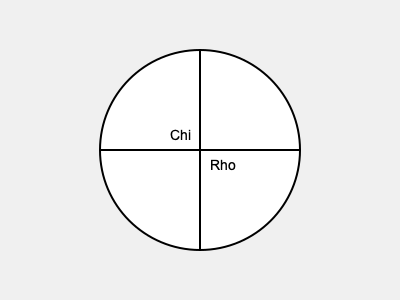What is the name of this important symbol in Episcopal worship, and what does it represent? 1. The symbol shown in the image is known as the Chi-Rho symbol.

2. It is composed of two Greek letters superimposed on each other:
   - The letter Chi (X), which looks like an X in the English alphabet
   - The letter Rho (P), which looks like a P in the English alphabet

3. These letters are the first two letters of the Greek word "Christos," meaning "Christ."

4. The Chi-Rho is one of the earliest Christian symbols, dating back to the 4th century AD.

5. In Episcopal worship, this symbol is often used to represent Jesus Christ and His role as the Messiah.

6. You might see the Chi-Rho symbol in various places in an Episcopal church, such as:
   - On altar cloths
   - In stained glass windows
   - On vestments worn by clergy
   - In church publications or bulletins

7. The use of this symbol connects Episcopal worship to the ancient traditions of the Christian faith and serves as a visual reminder of Christ's presence in the church.
Answer: Chi-Rho symbol; represents Jesus Christ 